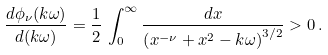Convert formula to latex. <formula><loc_0><loc_0><loc_500><loc_500>\frac { d \phi _ { \nu } ( k \omega ) } { d ( k \omega ) } = \frac { 1 } { 2 } \, \int _ { 0 } ^ { \infty } \frac { d x } { \left ( x ^ { - \nu } + x ^ { 2 } - k \omega \right ) ^ { 3 / 2 } } > 0 \, .</formula> 